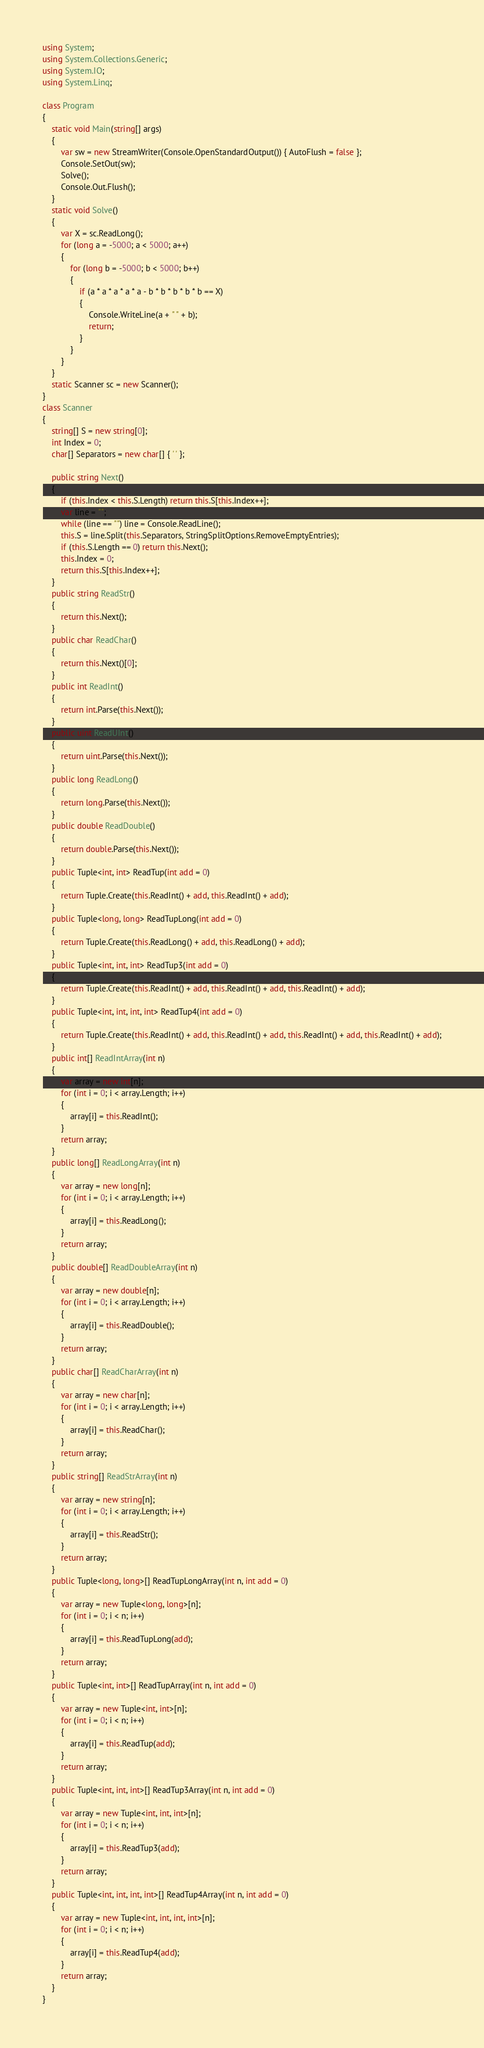Convert code to text. <code><loc_0><loc_0><loc_500><loc_500><_C#_>using System;
using System.Collections.Generic;
using System.IO;
using System.Linq;

class Program
{
    static void Main(string[] args)
    {
        var sw = new StreamWriter(Console.OpenStandardOutput()) { AutoFlush = false };
        Console.SetOut(sw);
        Solve();
        Console.Out.Flush();
    }
    static void Solve()
    {
        var X = sc.ReadLong();
        for (long a = -5000; a < 5000; a++)
        {
            for (long b = -5000; b < 5000; b++)
            {
                if (a * a * a * a * a - b * b * b * b * b == X)
                {
                    Console.WriteLine(a + " " + b);
                    return;
                }
            }
        }
    }
    static Scanner sc = new Scanner();
}
class Scanner
{
    string[] S = new string[0];
    int Index = 0;
    char[] Separators = new char[] { ' ' };

    public string Next()
    {
        if (this.Index < this.S.Length) return this.S[this.Index++];
        var line = "";
        while (line == "") line = Console.ReadLine();
        this.S = line.Split(this.Separators, StringSplitOptions.RemoveEmptyEntries);
        if (this.S.Length == 0) return this.Next();
        this.Index = 0;
        return this.S[this.Index++];
    }
    public string ReadStr()
    {
        return this.Next();
    }
    public char ReadChar()
    {
        return this.Next()[0];
    }
    public int ReadInt()
    {
        return int.Parse(this.Next());
    }
    public uint ReadUInt()
    {
        return uint.Parse(this.Next());
    }
    public long ReadLong()
    {
        return long.Parse(this.Next());
    }
    public double ReadDouble()
    {
        return double.Parse(this.Next());
    }
    public Tuple<int, int> ReadTup(int add = 0)
    {
        return Tuple.Create(this.ReadInt() + add, this.ReadInt() + add);
    }
    public Tuple<long, long> ReadTupLong(int add = 0)
    {
        return Tuple.Create(this.ReadLong() + add, this.ReadLong() + add);
    }
    public Tuple<int, int, int> ReadTup3(int add = 0)
    {
        return Tuple.Create(this.ReadInt() + add, this.ReadInt() + add, this.ReadInt() + add);
    }
    public Tuple<int, int, int, int> ReadTup4(int add = 0)
    {
        return Tuple.Create(this.ReadInt() + add, this.ReadInt() + add, this.ReadInt() + add, this.ReadInt() + add);
    }
    public int[] ReadIntArray(int n)
    {
        var array = new int[n];
        for (int i = 0; i < array.Length; i++)
        {
            array[i] = this.ReadInt();
        }
        return array;
    }
    public long[] ReadLongArray(int n)
    {
        var array = new long[n];
        for (int i = 0; i < array.Length; i++)
        {
            array[i] = this.ReadLong();
        }
        return array;
    }
    public double[] ReadDoubleArray(int n)
    {
        var array = new double[n];
        for (int i = 0; i < array.Length; i++)
        {
            array[i] = this.ReadDouble();
        }
        return array;
    }
    public char[] ReadCharArray(int n)
    {
        var array = new char[n];
        for (int i = 0; i < array.Length; i++)
        {
            array[i] = this.ReadChar();
        }
        return array;
    }
    public string[] ReadStrArray(int n)
    {
        var array = new string[n];
        for (int i = 0; i < array.Length; i++)
        {
            array[i] = this.ReadStr();
        }
        return array;
    }
    public Tuple<long, long>[] ReadTupLongArray(int n, int add = 0)
    {
        var array = new Tuple<long, long>[n];
        for (int i = 0; i < n; i++)
        {
            array[i] = this.ReadTupLong(add);
        }
        return array;
    }
    public Tuple<int, int>[] ReadTupArray(int n, int add = 0)
    {
        var array = new Tuple<int, int>[n];
        for (int i = 0; i < n; i++)
        {
            array[i] = this.ReadTup(add);
        }
        return array;
    }
    public Tuple<int, int, int>[] ReadTup3Array(int n, int add = 0)
    {
        var array = new Tuple<int, int, int>[n];
        for (int i = 0; i < n; i++)
        {
            array[i] = this.ReadTup3(add);
        }
        return array;
    }
    public Tuple<int, int, int, int>[] ReadTup4Array(int n, int add = 0)
    {
        var array = new Tuple<int, int, int, int>[n];
        for (int i = 0; i < n; i++)
        {
            array[i] = this.ReadTup4(add);
        }
        return array;
    }
}
</code> 